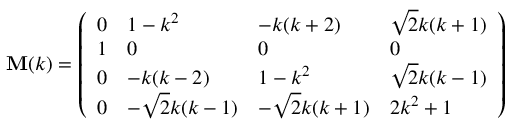Convert formula to latex. <formula><loc_0><loc_0><loc_500><loc_500>\begin{array} { r } { M ( k ) = \left ( \begin{array} { l l l l } { 0 } & { 1 - k ^ { 2 } } & { - k ( k + 2 ) } & { \sqrt { 2 } k ( k + 1 ) } \\ { 1 } & { 0 } & { 0 } & { 0 } \\ { 0 } & { - k ( k - 2 ) } & { 1 - k ^ { 2 } } & { \sqrt { 2 } k ( k - 1 ) } \\ { 0 } & { - \sqrt { 2 } k ( k - 1 ) } & { - \sqrt { 2 } k ( k + 1 ) } & { 2 k ^ { 2 } + 1 } \end{array} \right ) } \end{array}</formula> 